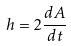<formula> <loc_0><loc_0><loc_500><loc_500>h = 2 \frac { d A } { d t }</formula> 